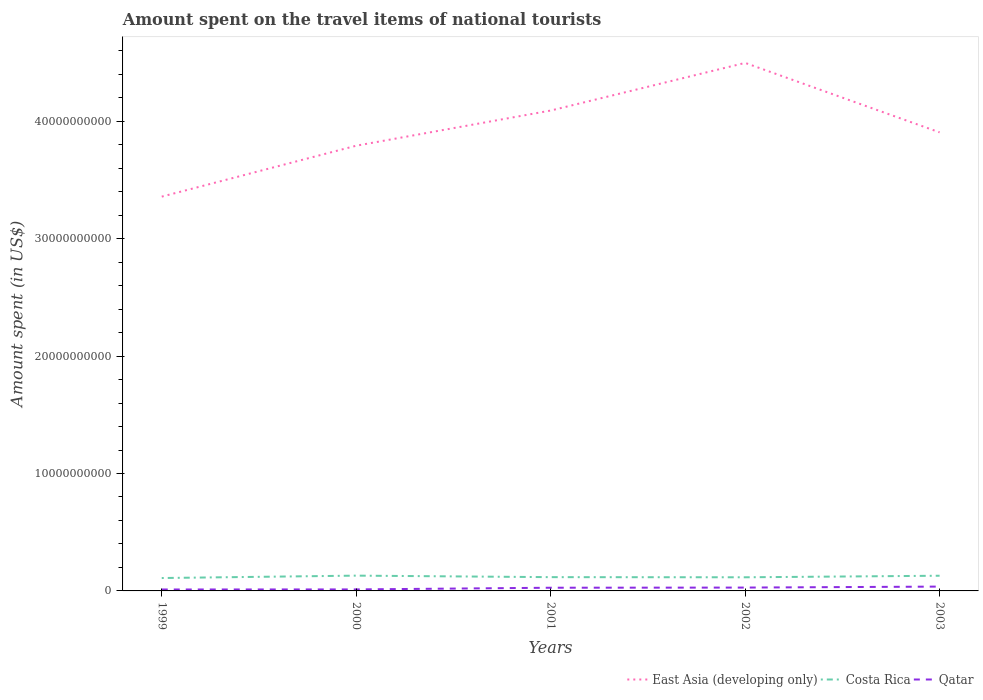How many different coloured lines are there?
Provide a succinct answer. 3. Across all years, what is the maximum amount spent on the travel items of national tourists in East Asia (developing only)?
Keep it short and to the point. 3.36e+1. What is the total amount spent on the travel items of national tourists in Costa Rica in the graph?
Provide a short and direct response. -6.30e+07. What is the difference between the highest and the second highest amount spent on the travel items of national tourists in Costa Rica?
Your answer should be very brief. 2.04e+08. Are the values on the major ticks of Y-axis written in scientific E-notation?
Offer a terse response. No. How many legend labels are there?
Provide a succinct answer. 3. What is the title of the graph?
Make the answer very short. Amount spent on the travel items of national tourists. What is the label or title of the X-axis?
Your answer should be very brief. Years. What is the label or title of the Y-axis?
Keep it short and to the point. Amount spent (in US$). What is the Amount spent (in US$) in East Asia (developing only) in 1999?
Give a very brief answer. 3.36e+1. What is the Amount spent (in US$) in Costa Rica in 1999?
Keep it short and to the point. 1.10e+09. What is the Amount spent (in US$) in Qatar in 1999?
Your answer should be very brief. 1.22e+08. What is the Amount spent (in US$) of East Asia (developing only) in 2000?
Your answer should be very brief. 3.79e+1. What is the Amount spent (in US$) in Costa Rica in 2000?
Keep it short and to the point. 1.30e+09. What is the Amount spent (in US$) of Qatar in 2000?
Keep it short and to the point. 1.28e+08. What is the Amount spent (in US$) of East Asia (developing only) in 2001?
Keep it short and to the point. 4.09e+1. What is the Amount spent (in US$) of Costa Rica in 2001?
Offer a very short reply. 1.17e+09. What is the Amount spent (in US$) of Qatar in 2001?
Your answer should be compact. 2.72e+08. What is the Amount spent (in US$) of East Asia (developing only) in 2002?
Keep it short and to the point. 4.50e+1. What is the Amount spent (in US$) in Costa Rica in 2002?
Keep it short and to the point. 1.16e+09. What is the Amount spent (in US$) of Qatar in 2002?
Give a very brief answer. 2.85e+08. What is the Amount spent (in US$) of East Asia (developing only) in 2003?
Provide a short and direct response. 3.91e+1. What is the Amount spent (in US$) of Costa Rica in 2003?
Your answer should be very brief. 1.29e+09. What is the Amount spent (in US$) of Qatar in 2003?
Your response must be concise. 3.69e+08. Across all years, what is the maximum Amount spent (in US$) in East Asia (developing only)?
Your answer should be very brief. 4.50e+1. Across all years, what is the maximum Amount spent (in US$) of Costa Rica?
Keep it short and to the point. 1.30e+09. Across all years, what is the maximum Amount spent (in US$) in Qatar?
Your answer should be very brief. 3.69e+08. Across all years, what is the minimum Amount spent (in US$) of East Asia (developing only)?
Your answer should be very brief. 3.36e+1. Across all years, what is the minimum Amount spent (in US$) in Costa Rica?
Make the answer very short. 1.10e+09. Across all years, what is the minimum Amount spent (in US$) in Qatar?
Your answer should be very brief. 1.22e+08. What is the total Amount spent (in US$) in East Asia (developing only) in the graph?
Your answer should be compact. 1.96e+11. What is the total Amount spent (in US$) in Costa Rica in the graph?
Your answer should be compact. 6.03e+09. What is the total Amount spent (in US$) in Qatar in the graph?
Provide a succinct answer. 1.18e+09. What is the difference between the Amount spent (in US$) of East Asia (developing only) in 1999 and that in 2000?
Offer a terse response. -4.34e+09. What is the difference between the Amount spent (in US$) of Costa Rica in 1999 and that in 2000?
Your response must be concise. -2.04e+08. What is the difference between the Amount spent (in US$) in Qatar in 1999 and that in 2000?
Give a very brief answer. -6.00e+06. What is the difference between the Amount spent (in US$) in East Asia (developing only) in 1999 and that in 2001?
Give a very brief answer. -7.33e+09. What is the difference between the Amount spent (in US$) in Costa Rica in 1999 and that in 2001?
Keep it short and to the point. -7.50e+07. What is the difference between the Amount spent (in US$) of Qatar in 1999 and that in 2001?
Ensure brevity in your answer.  -1.50e+08. What is the difference between the Amount spent (in US$) of East Asia (developing only) in 1999 and that in 2002?
Make the answer very short. -1.14e+1. What is the difference between the Amount spent (in US$) of Costa Rica in 1999 and that in 2002?
Offer a very short reply. -6.30e+07. What is the difference between the Amount spent (in US$) of Qatar in 1999 and that in 2002?
Provide a short and direct response. -1.63e+08. What is the difference between the Amount spent (in US$) of East Asia (developing only) in 1999 and that in 2003?
Ensure brevity in your answer.  -5.47e+09. What is the difference between the Amount spent (in US$) in Costa Rica in 1999 and that in 2003?
Keep it short and to the point. -1.95e+08. What is the difference between the Amount spent (in US$) of Qatar in 1999 and that in 2003?
Offer a very short reply. -2.47e+08. What is the difference between the Amount spent (in US$) in East Asia (developing only) in 2000 and that in 2001?
Your answer should be very brief. -2.99e+09. What is the difference between the Amount spent (in US$) of Costa Rica in 2000 and that in 2001?
Ensure brevity in your answer.  1.29e+08. What is the difference between the Amount spent (in US$) in Qatar in 2000 and that in 2001?
Give a very brief answer. -1.44e+08. What is the difference between the Amount spent (in US$) in East Asia (developing only) in 2000 and that in 2002?
Offer a very short reply. -7.05e+09. What is the difference between the Amount spent (in US$) in Costa Rica in 2000 and that in 2002?
Give a very brief answer. 1.41e+08. What is the difference between the Amount spent (in US$) of Qatar in 2000 and that in 2002?
Provide a short and direct response. -1.57e+08. What is the difference between the Amount spent (in US$) in East Asia (developing only) in 2000 and that in 2003?
Provide a short and direct response. -1.14e+09. What is the difference between the Amount spent (in US$) of Costa Rica in 2000 and that in 2003?
Your answer should be very brief. 9.00e+06. What is the difference between the Amount spent (in US$) in Qatar in 2000 and that in 2003?
Provide a short and direct response. -2.41e+08. What is the difference between the Amount spent (in US$) of East Asia (developing only) in 2001 and that in 2002?
Provide a succinct answer. -4.06e+09. What is the difference between the Amount spent (in US$) of Costa Rica in 2001 and that in 2002?
Keep it short and to the point. 1.20e+07. What is the difference between the Amount spent (in US$) of Qatar in 2001 and that in 2002?
Your answer should be very brief. -1.30e+07. What is the difference between the Amount spent (in US$) in East Asia (developing only) in 2001 and that in 2003?
Provide a succinct answer. 1.86e+09. What is the difference between the Amount spent (in US$) in Costa Rica in 2001 and that in 2003?
Your response must be concise. -1.20e+08. What is the difference between the Amount spent (in US$) in Qatar in 2001 and that in 2003?
Offer a very short reply. -9.70e+07. What is the difference between the Amount spent (in US$) of East Asia (developing only) in 2002 and that in 2003?
Offer a very short reply. 5.91e+09. What is the difference between the Amount spent (in US$) in Costa Rica in 2002 and that in 2003?
Provide a succinct answer. -1.32e+08. What is the difference between the Amount spent (in US$) in Qatar in 2002 and that in 2003?
Offer a very short reply. -8.40e+07. What is the difference between the Amount spent (in US$) in East Asia (developing only) in 1999 and the Amount spent (in US$) in Costa Rica in 2000?
Give a very brief answer. 3.23e+1. What is the difference between the Amount spent (in US$) in East Asia (developing only) in 1999 and the Amount spent (in US$) in Qatar in 2000?
Give a very brief answer. 3.34e+1. What is the difference between the Amount spent (in US$) in Costa Rica in 1999 and the Amount spent (in US$) in Qatar in 2000?
Ensure brevity in your answer.  9.70e+08. What is the difference between the Amount spent (in US$) of East Asia (developing only) in 1999 and the Amount spent (in US$) of Costa Rica in 2001?
Provide a succinct answer. 3.24e+1. What is the difference between the Amount spent (in US$) of East Asia (developing only) in 1999 and the Amount spent (in US$) of Qatar in 2001?
Your answer should be very brief. 3.33e+1. What is the difference between the Amount spent (in US$) in Costa Rica in 1999 and the Amount spent (in US$) in Qatar in 2001?
Provide a succinct answer. 8.26e+08. What is the difference between the Amount spent (in US$) of East Asia (developing only) in 1999 and the Amount spent (in US$) of Costa Rica in 2002?
Keep it short and to the point. 3.24e+1. What is the difference between the Amount spent (in US$) in East Asia (developing only) in 1999 and the Amount spent (in US$) in Qatar in 2002?
Provide a short and direct response. 3.33e+1. What is the difference between the Amount spent (in US$) of Costa Rica in 1999 and the Amount spent (in US$) of Qatar in 2002?
Offer a very short reply. 8.13e+08. What is the difference between the Amount spent (in US$) in East Asia (developing only) in 1999 and the Amount spent (in US$) in Costa Rica in 2003?
Provide a succinct answer. 3.23e+1. What is the difference between the Amount spent (in US$) in East Asia (developing only) in 1999 and the Amount spent (in US$) in Qatar in 2003?
Ensure brevity in your answer.  3.32e+1. What is the difference between the Amount spent (in US$) in Costa Rica in 1999 and the Amount spent (in US$) in Qatar in 2003?
Offer a very short reply. 7.29e+08. What is the difference between the Amount spent (in US$) of East Asia (developing only) in 2000 and the Amount spent (in US$) of Costa Rica in 2001?
Offer a very short reply. 3.67e+1. What is the difference between the Amount spent (in US$) of East Asia (developing only) in 2000 and the Amount spent (in US$) of Qatar in 2001?
Your response must be concise. 3.76e+1. What is the difference between the Amount spent (in US$) in Costa Rica in 2000 and the Amount spent (in US$) in Qatar in 2001?
Ensure brevity in your answer.  1.03e+09. What is the difference between the Amount spent (in US$) in East Asia (developing only) in 2000 and the Amount spent (in US$) in Costa Rica in 2002?
Make the answer very short. 3.68e+1. What is the difference between the Amount spent (in US$) in East Asia (developing only) in 2000 and the Amount spent (in US$) in Qatar in 2002?
Provide a short and direct response. 3.76e+1. What is the difference between the Amount spent (in US$) in Costa Rica in 2000 and the Amount spent (in US$) in Qatar in 2002?
Ensure brevity in your answer.  1.02e+09. What is the difference between the Amount spent (in US$) of East Asia (developing only) in 2000 and the Amount spent (in US$) of Costa Rica in 2003?
Give a very brief answer. 3.66e+1. What is the difference between the Amount spent (in US$) of East Asia (developing only) in 2000 and the Amount spent (in US$) of Qatar in 2003?
Keep it short and to the point. 3.75e+1. What is the difference between the Amount spent (in US$) of Costa Rica in 2000 and the Amount spent (in US$) of Qatar in 2003?
Provide a succinct answer. 9.33e+08. What is the difference between the Amount spent (in US$) in East Asia (developing only) in 2001 and the Amount spent (in US$) in Costa Rica in 2002?
Make the answer very short. 3.97e+1. What is the difference between the Amount spent (in US$) of East Asia (developing only) in 2001 and the Amount spent (in US$) of Qatar in 2002?
Your answer should be very brief. 4.06e+1. What is the difference between the Amount spent (in US$) in Costa Rica in 2001 and the Amount spent (in US$) in Qatar in 2002?
Keep it short and to the point. 8.88e+08. What is the difference between the Amount spent (in US$) of East Asia (developing only) in 2001 and the Amount spent (in US$) of Costa Rica in 2003?
Your answer should be very brief. 3.96e+1. What is the difference between the Amount spent (in US$) of East Asia (developing only) in 2001 and the Amount spent (in US$) of Qatar in 2003?
Offer a very short reply. 4.05e+1. What is the difference between the Amount spent (in US$) in Costa Rica in 2001 and the Amount spent (in US$) in Qatar in 2003?
Offer a terse response. 8.04e+08. What is the difference between the Amount spent (in US$) in East Asia (developing only) in 2002 and the Amount spent (in US$) in Costa Rica in 2003?
Your response must be concise. 4.37e+1. What is the difference between the Amount spent (in US$) in East Asia (developing only) in 2002 and the Amount spent (in US$) in Qatar in 2003?
Keep it short and to the point. 4.46e+1. What is the difference between the Amount spent (in US$) in Costa Rica in 2002 and the Amount spent (in US$) in Qatar in 2003?
Your answer should be compact. 7.92e+08. What is the average Amount spent (in US$) of East Asia (developing only) per year?
Your answer should be compact. 3.93e+1. What is the average Amount spent (in US$) in Costa Rica per year?
Provide a succinct answer. 1.21e+09. What is the average Amount spent (in US$) of Qatar per year?
Offer a very short reply. 2.35e+08. In the year 1999, what is the difference between the Amount spent (in US$) in East Asia (developing only) and Amount spent (in US$) in Costa Rica?
Provide a short and direct response. 3.25e+1. In the year 1999, what is the difference between the Amount spent (in US$) in East Asia (developing only) and Amount spent (in US$) in Qatar?
Your response must be concise. 3.35e+1. In the year 1999, what is the difference between the Amount spent (in US$) of Costa Rica and Amount spent (in US$) of Qatar?
Provide a succinct answer. 9.76e+08. In the year 2000, what is the difference between the Amount spent (in US$) in East Asia (developing only) and Amount spent (in US$) in Costa Rica?
Your answer should be compact. 3.66e+1. In the year 2000, what is the difference between the Amount spent (in US$) of East Asia (developing only) and Amount spent (in US$) of Qatar?
Keep it short and to the point. 3.78e+1. In the year 2000, what is the difference between the Amount spent (in US$) in Costa Rica and Amount spent (in US$) in Qatar?
Keep it short and to the point. 1.17e+09. In the year 2001, what is the difference between the Amount spent (in US$) in East Asia (developing only) and Amount spent (in US$) in Costa Rica?
Provide a short and direct response. 3.97e+1. In the year 2001, what is the difference between the Amount spent (in US$) in East Asia (developing only) and Amount spent (in US$) in Qatar?
Your response must be concise. 4.06e+1. In the year 2001, what is the difference between the Amount spent (in US$) of Costa Rica and Amount spent (in US$) of Qatar?
Offer a very short reply. 9.01e+08. In the year 2002, what is the difference between the Amount spent (in US$) in East Asia (developing only) and Amount spent (in US$) in Costa Rica?
Your answer should be very brief. 4.38e+1. In the year 2002, what is the difference between the Amount spent (in US$) in East Asia (developing only) and Amount spent (in US$) in Qatar?
Provide a succinct answer. 4.47e+1. In the year 2002, what is the difference between the Amount spent (in US$) of Costa Rica and Amount spent (in US$) of Qatar?
Keep it short and to the point. 8.76e+08. In the year 2003, what is the difference between the Amount spent (in US$) in East Asia (developing only) and Amount spent (in US$) in Costa Rica?
Your answer should be very brief. 3.78e+1. In the year 2003, what is the difference between the Amount spent (in US$) of East Asia (developing only) and Amount spent (in US$) of Qatar?
Ensure brevity in your answer.  3.87e+1. In the year 2003, what is the difference between the Amount spent (in US$) in Costa Rica and Amount spent (in US$) in Qatar?
Offer a very short reply. 9.24e+08. What is the ratio of the Amount spent (in US$) in East Asia (developing only) in 1999 to that in 2000?
Your answer should be very brief. 0.89. What is the ratio of the Amount spent (in US$) in Costa Rica in 1999 to that in 2000?
Offer a very short reply. 0.84. What is the ratio of the Amount spent (in US$) in Qatar in 1999 to that in 2000?
Keep it short and to the point. 0.95. What is the ratio of the Amount spent (in US$) in East Asia (developing only) in 1999 to that in 2001?
Offer a very short reply. 0.82. What is the ratio of the Amount spent (in US$) of Costa Rica in 1999 to that in 2001?
Your answer should be very brief. 0.94. What is the ratio of the Amount spent (in US$) of Qatar in 1999 to that in 2001?
Make the answer very short. 0.45. What is the ratio of the Amount spent (in US$) in East Asia (developing only) in 1999 to that in 2002?
Offer a very short reply. 0.75. What is the ratio of the Amount spent (in US$) of Costa Rica in 1999 to that in 2002?
Offer a very short reply. 0.95. What is the ratio of the Amount spent (in US$) of Qatar in 1999 to that in 2002?
Give a very brief answer. 0.43. What is the ratio of the Amount spent (in US$) in East Asia (developing only) in 1999 to that in 2003?
Ensure brevity in your answer.  0.86. What is the ratio of the Amount spent (in US$) in Costa Rica in 1999 to that in 2003?
Keep it short and to the point. 0.85. What is the ratio of the Amount spent (in US$) in Qatar in 1999 to that in 2003?
Make the answer very short. 0.33. What is the ratio of the Amount spent (in US$) in East Asia (developing only) in 2000 to that in 2001?
Give a very brief answer. 0.93. What is the ratio of the Amount spent (in US$) in Costa Rica in 2000 to that in 2001?
Provide a short and direct response. 1.11. What is the ratio of the Amount spent (in US$) in Qatar in 2000 to that in 2001?
Give a very brief answer. 0.47. What is the ratio of the Amount spent (in US$) of East Asia (developing only) in 2000 to that in 2002?
Ensure brevity in your answer.  0.84. What is the ratio of the Amount spent (in US$) in Costa Rica in 2000 to that in 2002?
Ensure brevity in your answer.  1.12. What is the ratio of the Amount spent (in US$) in Qatar in 2000 to that in 2002?
Provide a succinct answer. 0.45. What is the ratio of the Amount spent (in US$) of East Asia (developing only) in 2000 to that in 2003?
Ensure brevity in your answer.  0.97. What is the ratio of the Amount spent (in US$) in Costa Rica in 2000 to that in 2003?
Offer a very short reply. 1.01. What is the ratio of the Amount spent (in US$) of Qatar in 2000 to that in 2003?
Offer a terse response. 0.35. What is the ratio of the Amount spent (in US$) of East Asia (developing only) in 2001 to that in 2002?
Make the answer very short. 0.91. What is the ratio of the Amount spent (in US$) in Costa Rica in 2001 to that in 2002?
Your answer should be compact. 1.01. What is the ratio of the Amount spent (in US$) in Qatar in 2001 to that in 2002?
Provide a succinct answer. 0.95. What is the ratio of the Amount spent (in US$) of East Asia (developing only) in 2001 to that in 2003?
Offer a very short reply. 1.05. What is the ratio of the Amount spent (in US$) in Costa Rica in 2001 to that in 2003?
Provide a short and direct response. 0.91. What is the ratio of the Amount spent (in US$) in Qatar in 2001 to that in 2003?
Provide a succinct answer. 0.74. What is the ratio of the Amount spent (in US$) in East Asia (developing only) in 2002 to that in 2003?
Offer a very short reply. 1.15. What is the ratio of the Amount spent (in US$) in Costa Rica in 2002 to that in 2003?
Provide a succinct answer. 0.9. What is the ratio of the Amount spent (in US$) of Qatar in 2002 to that in 2003?
Your response must be concise. 0.77. What is the difference between the highest and the second highest Amount spent (in US$) in East Asia (developing only)?
Give a very brief answer. 4.06e+09. What is the difference between the highest and the second highest Amount spent (in US$) in Costa Rica?
Offer a very short reply. 9.00e+06. What is the difference between the highest and the second highest Amount spent (in US$) of Qatar?
Offer a terse response. 8.40e+07. What is the difference between the highest and the lowest Amount spent (in US$) of East Asia (developing only)?
Give a very brief answer. 1.14e+1. What is the difference between the highest and the lowest Amount spent (in US$) in Costa Rica?
Keep it short and to the point. 2.04e+08. What is the difference between the highest and the lowest Amount spent (in US$) of Qatar?
Offer a terse response. 2.47e+08. 